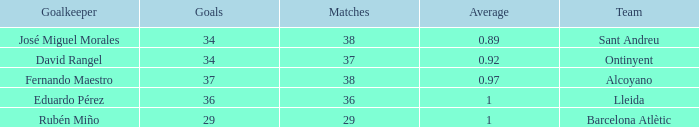What is the highest Average, when Goals is "34", and when Matches is less than 37? None. 